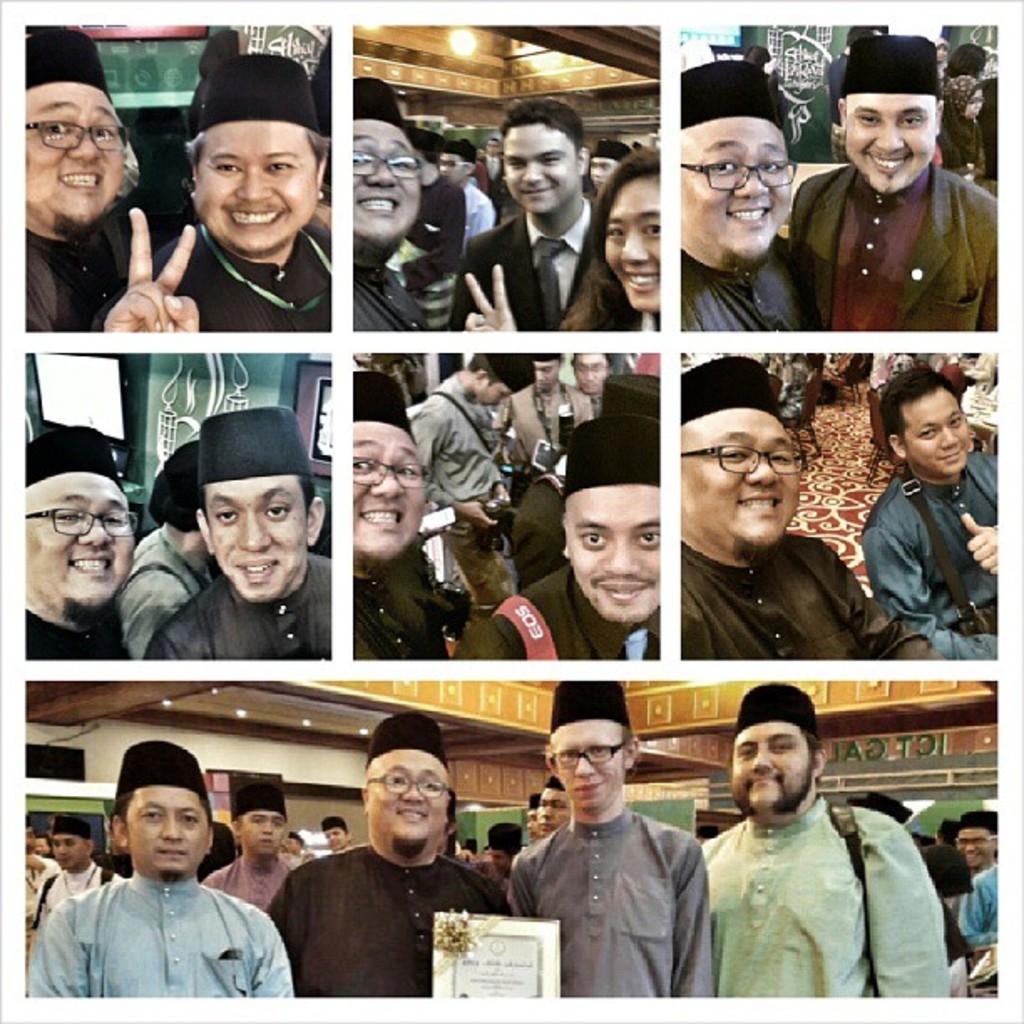Describe this image in one or two sentences. In this image there is a collage of photos. Bottom of the image there are few persons wearing caps. Before them there is a frame having some text on it. 